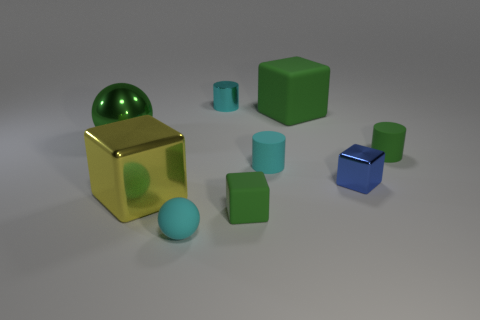Does the metallic sphere have the same size as the cyan thing to the left of the metal cylinder?
Your answer should be very brief. No. How many shiny objects are tiny cylinders or gray blocks?
Your answer should be compact. 1. What number of green shiny objects are the same shape as the large matte object?
Keep it short and to the point. 0. There is another big object that is the same color as the big rubber object; what is it made of?
Make the answer very short. Metal. Is the size of the matte thing that is right of the tiny blue thing the same as the cyan thing in front of the small rubber block?
Offer a terse response. Yes. What shape is the tiny green matte object in front of the big yellow cube?
Offer a terse response. Cube. There is a tiny blue object that is the same shape as the big yellow metallic thing; what material is it?
Ensure brevity in your answer.  Metal. Does the cyan cylinder that is in front of the green ball have the same size as the blue object?
Your answer should be compact. Yes. There is a tiny cyan matte ball; how many green metallic spheres are on the right side of it?
Give a very brief answer. 0. Are there fewer cyan matte objects in front of the blue object than things right of the large green shiny object?
Provide a short and direct response. Yes. 